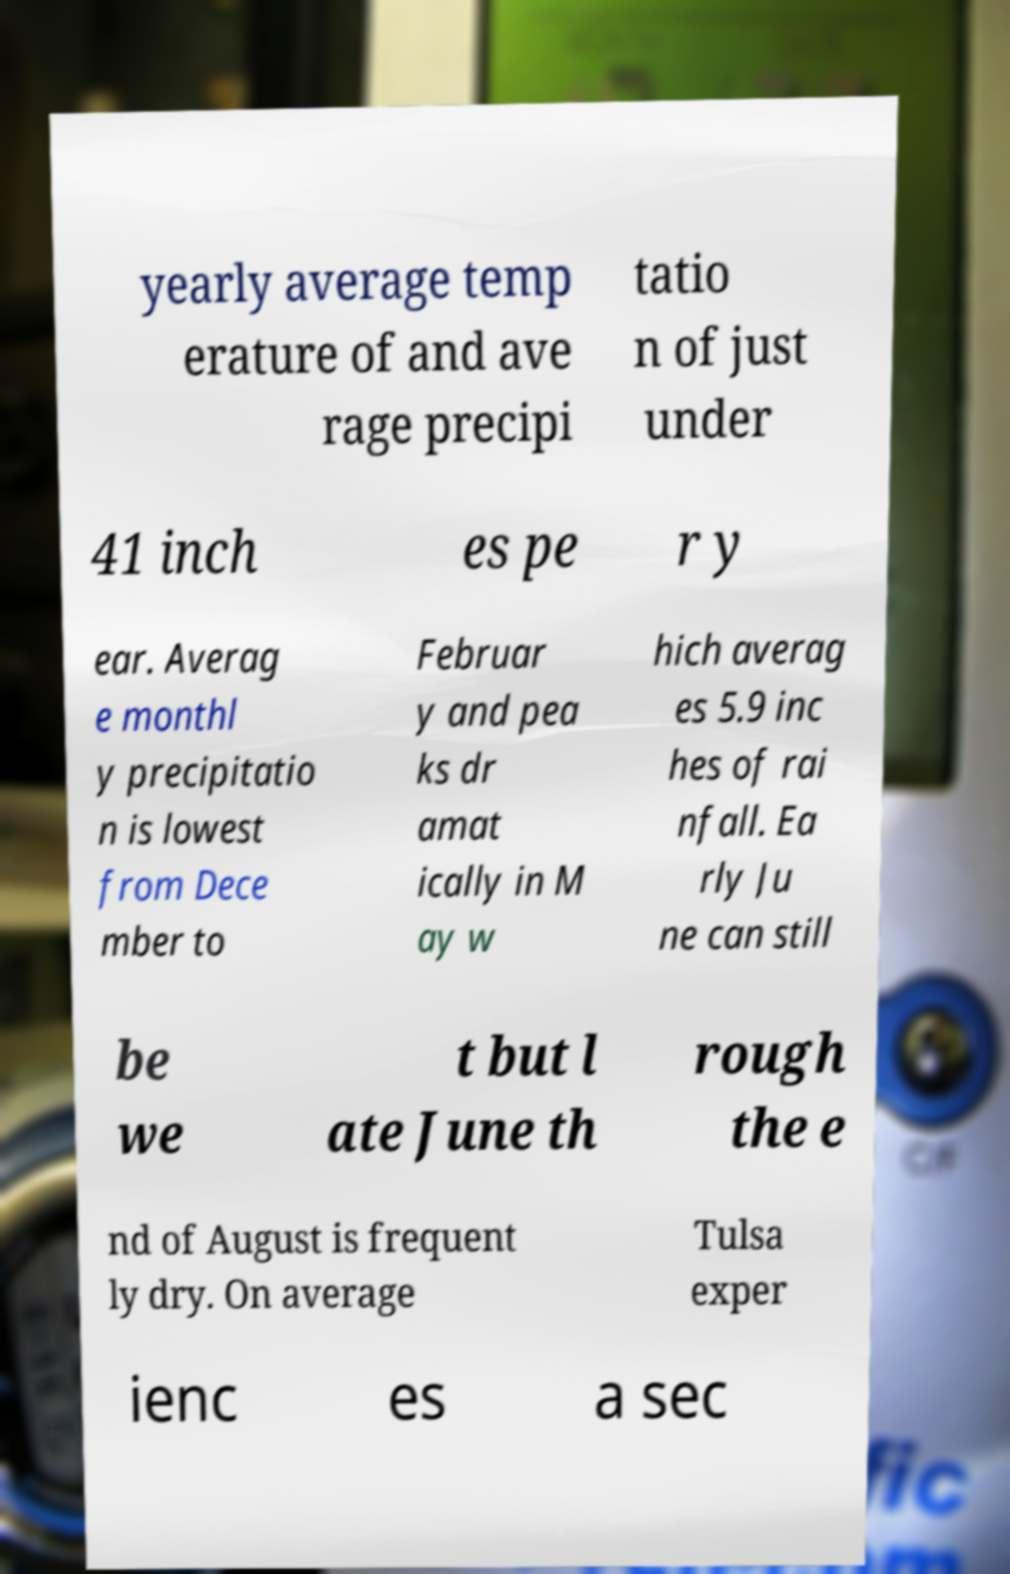Could you assist in decoding the text presented in this image and type it out clearly? yearly average temp erature of and ave rage precipi tatio n of just under 41 inch es pe r y ear. Averag e monthl y precipitatio n is lowest from Dece mber to Februar y and pea ks dr amat ically in M ay w hich averag es 5.9 inc hes of rai nfall. Ea rly Ju ne can still be we t but l ate June th rough the e nd of August is frequent ly dry. On average Tulsa exper ienc es a sec 